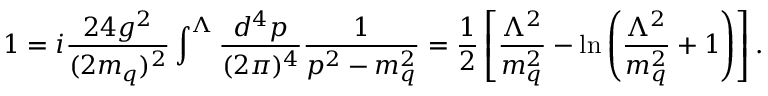<formula> <loc_0><loc_0><loc_500><loc_500>1 = i { \frac { 2 4 g ^ { 2 } } { ( 2 m _ { q } ) ^ { 2 } } } \int ^ { \Lambda } { \frac { d ^ { 4 } p } { ( 2 \pi ) ^ { 4 } } } { \frac { 1 } { p ^ { 2 } - m _ { q } ^ { 2 } } } = { \frac { 1 } { 2 } } \left [ { \frac { \Lambda ^ { 2 } } { m _ { q } ^ { 2 } } } - \ln \left ( { \frac { \Lambda ^ { 2 } } { m _ { q } ^ { 2 } } } + 1 \right ) \right ] .</formula> 